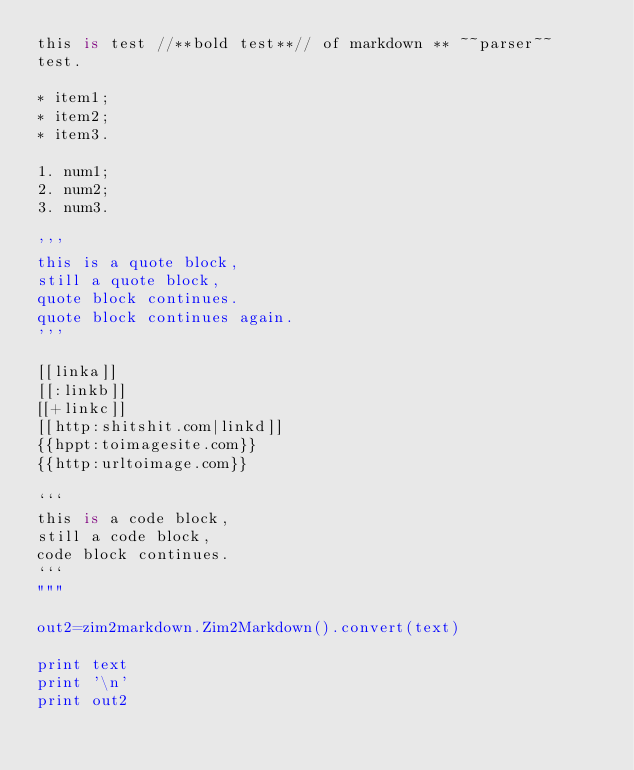<code> <loc_0><loc_0><loc_500><loc_500><_Python_>this is test //**bold test**// of markdown ** ~~parser~~
test.

* item1;
* item2;
* item3.

1. num1;
2. num2;
3. num3.

'''
this is a quote block,
still a quote block,
quote block continues.
quote block continues again.
'''

[[linka]]
[[:linkb]]
[[+linkc]]
[[http:shitshit.com|linkd]]
{{hppt:toimagesite.com}}
{{http:urltoimage.com}}

```
this is a code block,
still a code block,
code block continues.
```
"""

out2=zim2markdown.Zim2Markdown().convert(text)

print text
print '\n'
print out2
</code> 